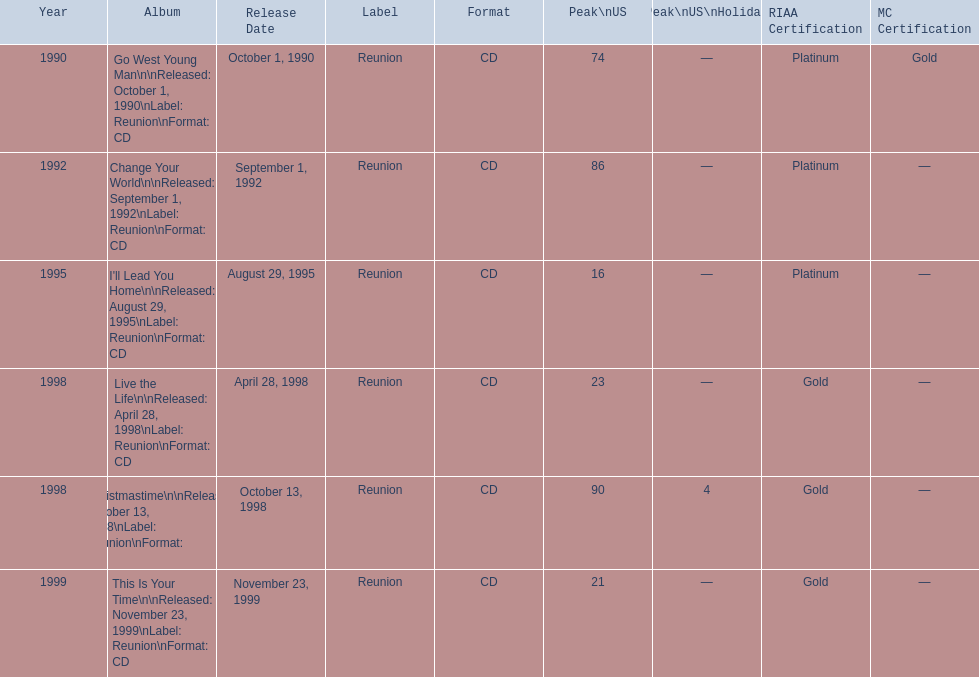The oldest year listed is what? 1990. 